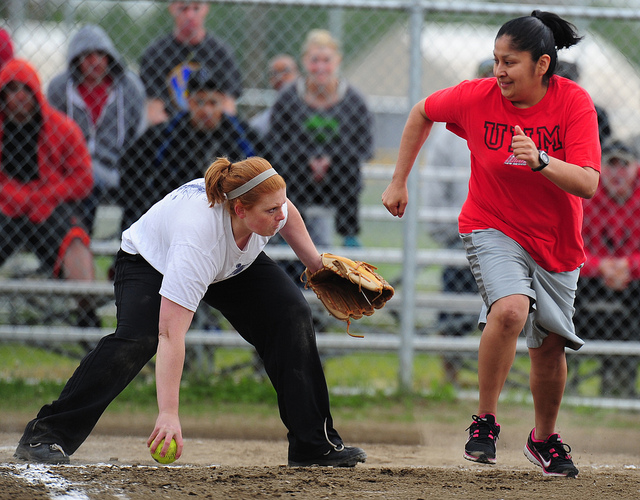<image>What color hair does the woman walking have? I don't know the exact color of the woman's hair. It can be black, red, ginger, or blonde. What color hair does the woman walking have? It is ambiguous what color hair the woman walking has. It can be seen black, red, ginger, or blonde. 